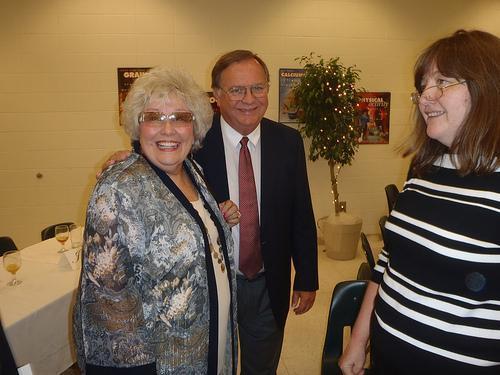How many glasses are on the table?
Give a very brief answer. 2. How many people are wearing a tie?
Give a very brief answer. 1. 